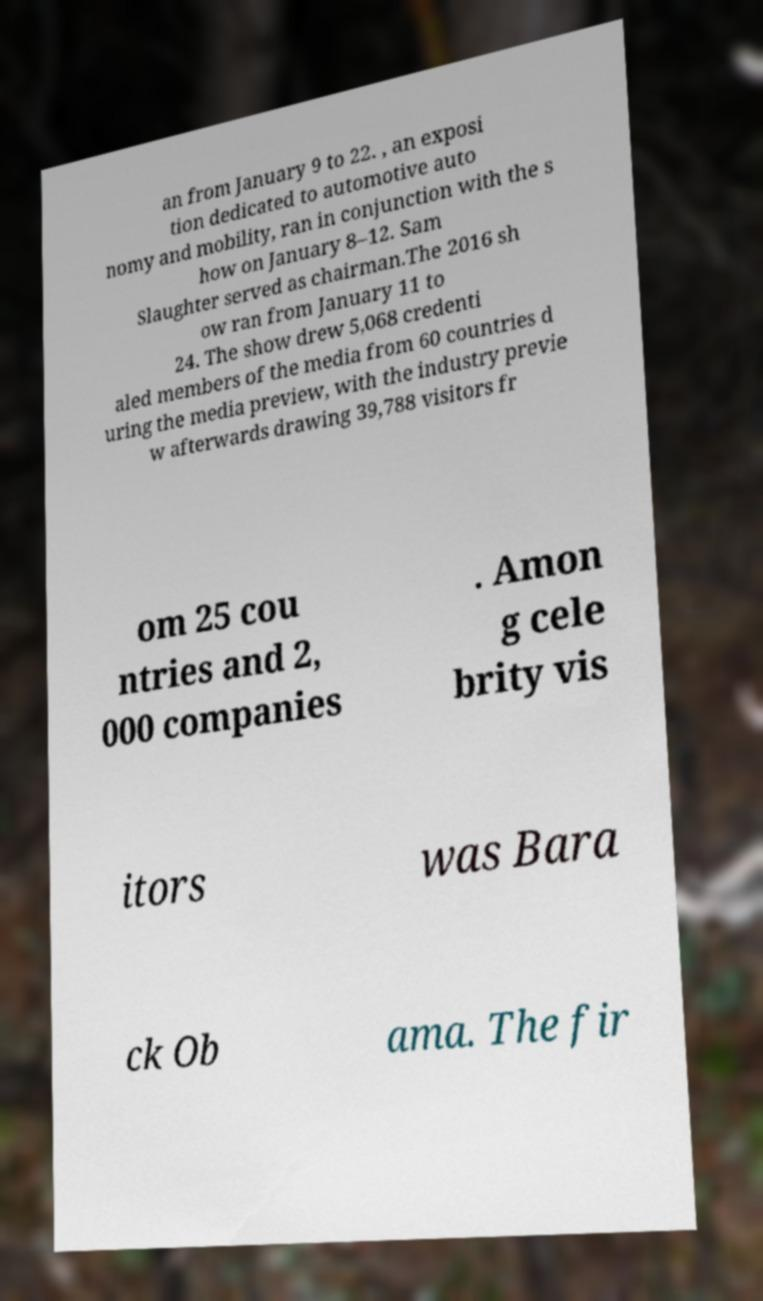Can you accurately transcribe the text from the provided image for me? an from January 9 to 22. , an exposi tion dedicated to automotive auto nomy and mobility, ran in conjunction with the s how on January 8–12. Sam Slaughter served as chairman.The 2016 sh ow ran from January 11 to 24. The show drew 5,068 credenti aled members of the media from 60 countries d uring the media preview, with the industry previe w afterwards drawing 39,788 visitors fr om 25 cou ntries and 2, 000 companies . Amon g cele brity vis itors was Bara ck Ob ama. The fir 